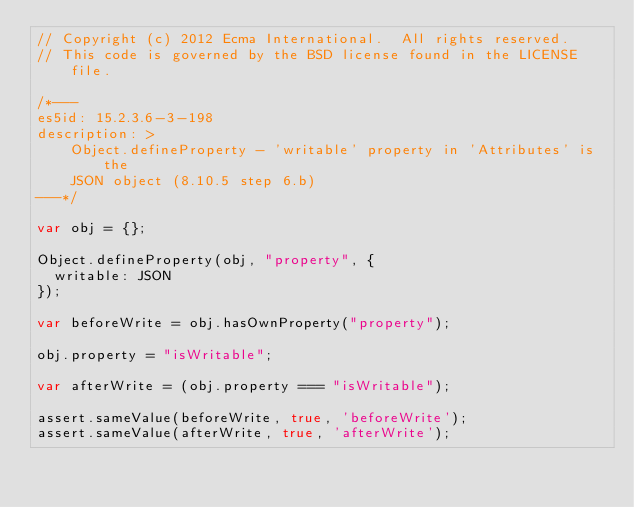<code> <loc_0><loc_0><loc_500><loc_500><_JavaScript_>// Copyright (c) 2012 Ecma International.  All rights reserved.
// This code is governed by the BSD license found in the LICENSE file.

/*---
es5id: 15.2.3.6-3-198
description: >
    Object.defineProperty - 'writable' property in 'Attributes' is the
    JSON object (8.10.5 step 6.b)
---*/

var obj = {};

Object.defineProperty(obj, "property", {
  writable: JSON
});

var beforeWrite = obj.hasOwnProperty("property");

obj.property = "isWritable";

var afterWrite = (obj.property === "isWritable");

assert.sameValue(beforeWrite, true, 'beforeWrite');
assert.sameValue(afterWrite, true, 'afterWrite');
</code> 